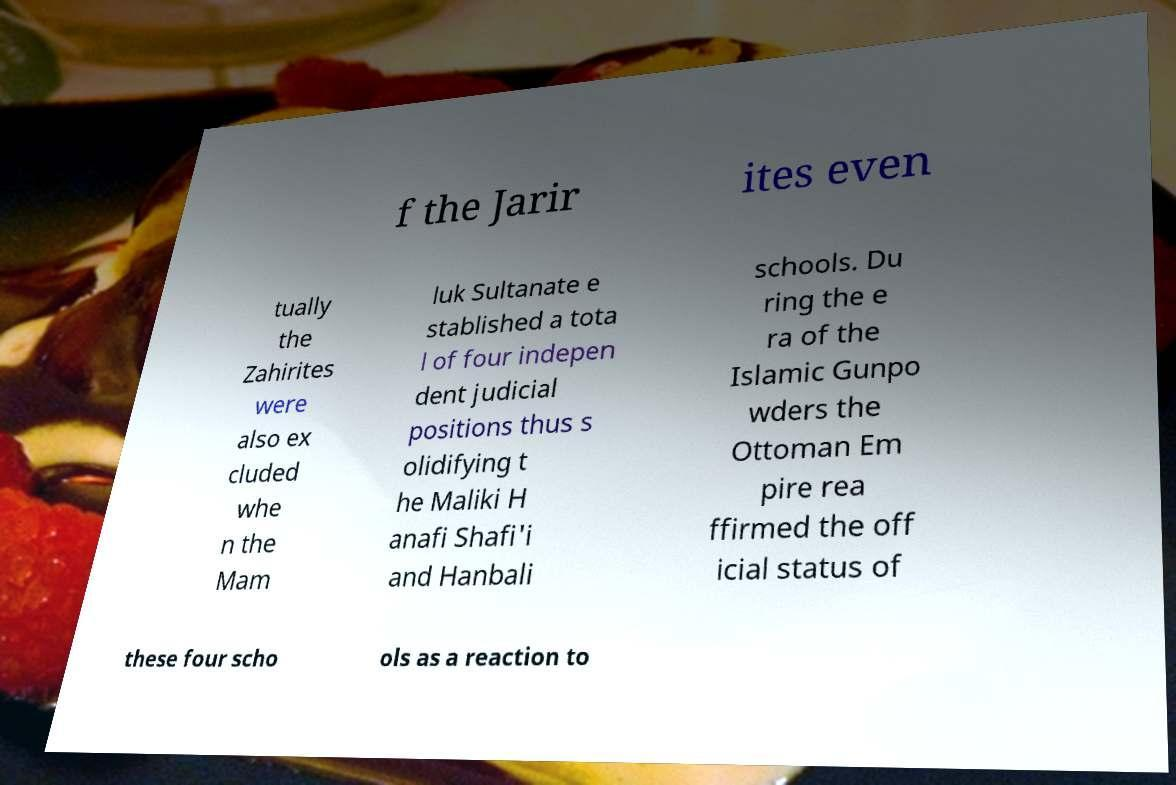There's text embedded in this image that I need extracted. Can you transcribe it verbatim? f the Jarir ites even tually the Zahirites were also ex cluded whe n the Mam luk Sultanate e stablished a tota l of four indepen dent judicial positions thus s olidifying t he Maliki H anafi Shafi'i and Hanbali schools. Du ring the e ra of the Islamic Gunpo wders the Ottoman Em pire rea ffirmed the off icial status of these four scho ols as a reaction to 